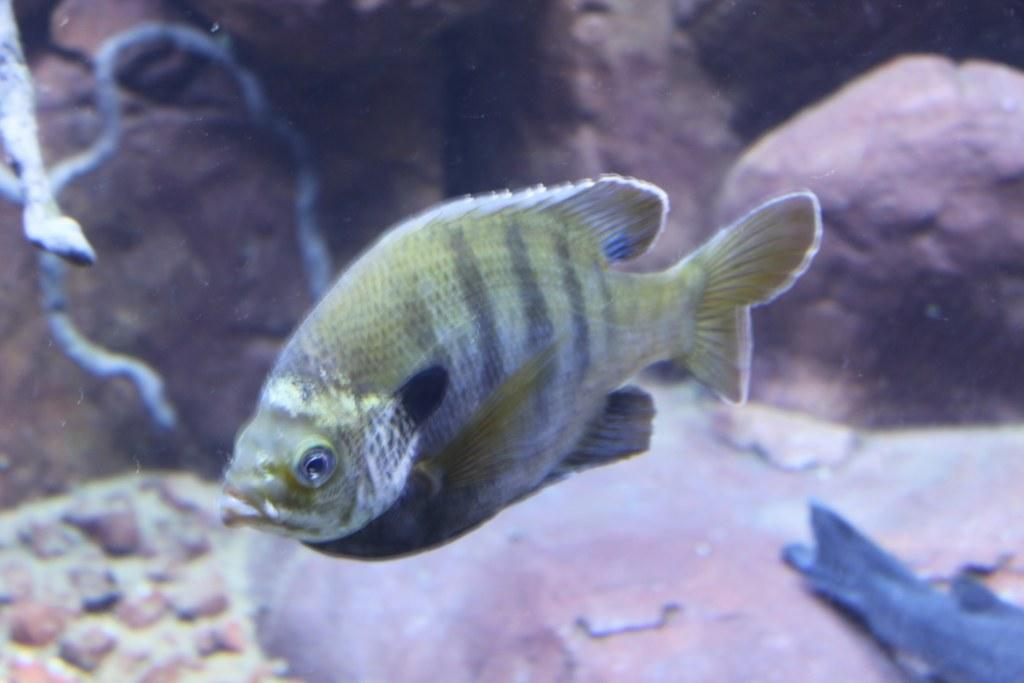What animals can be seen in the water in the image? There are two fish in the water in the image. What can be seen on the left side of the image? There is a grey color thing on the left side of the image. How would you describe the overall clarity of the image? The image is slightly blurry. Can you see any plantation in the image? There is no plantation present in the image. Are there any squirrels visible in the image? There are no squirrels visible in the image. 